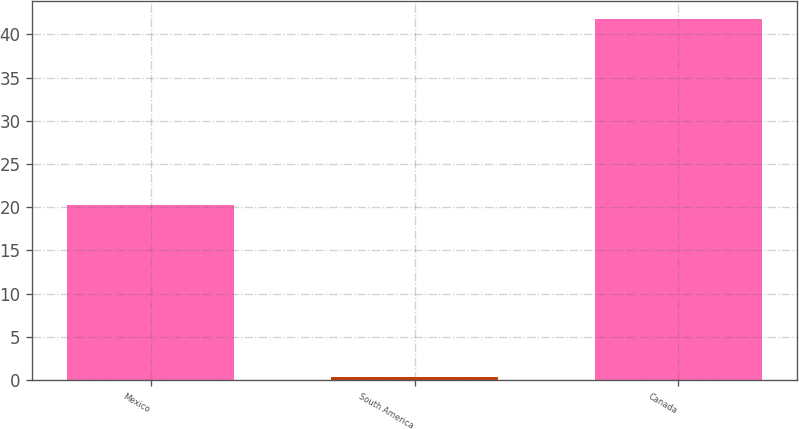Convert chart. <chart><loc_0><loc_0><loc_500><loc_500><bar_chart><fcel>Mexico<fcel>South America<fcel>Canada<nl><fcel>20.3<fcel>0.4<fcel>41.8<nl></chart> 